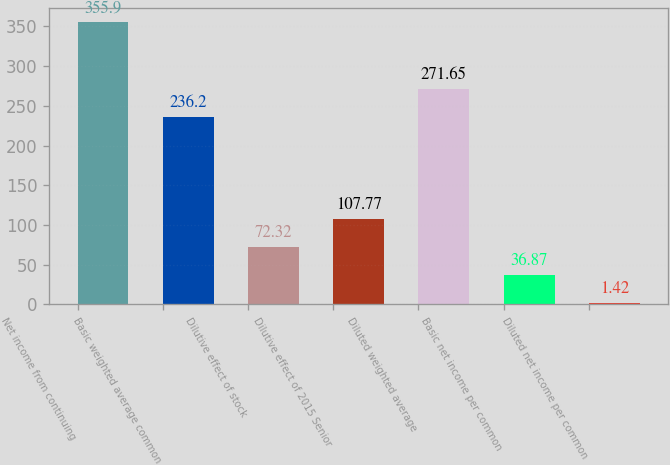Convert chart to OTSL. <chart><loc_0><loc_0><loc_500><loc_500><bar_chart><fcel>Net income from continuing<fcel>Basic weighted average common<fcel>Dilutive effect of stock<fcel>Dilutive effect of 2015 Senior<fcel>Diluted weighted average<fcel>Basic net income per common<fcel>Diluted net income per common<nl><fcel>355.9<fcel>236.2<fcel>72.32<fcel>107.77<fcel>271.65<fcel>36.87<fcel>1.42<nl></chart> 